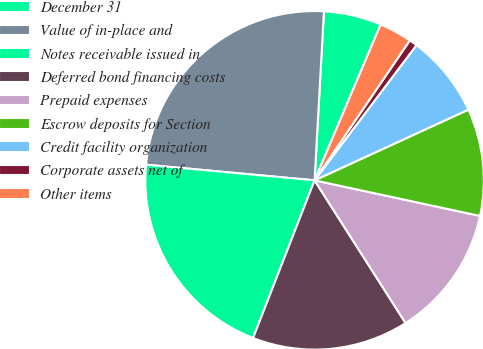<chart> <loc_0><loc_0><loc_500><loc_500><pie_chart><fcel>December 31<fcel>Value of in-place and<fcel>Notes receivable issued in<fcel>Deferred bond financing costs<fcel>Prepaid expenses<fcel>Escrow deposits for Section<fcel>Credit facility organization<fcel>Corporate assets net of<fcel>Other items<nl><fcel>5.5%<fcel>24.41%<fcel>20.55%<fcel>14.95%<fcel>12.59%<fcel>10.23%<fcel>7.86%<fcel>0.77%<fcel>3.13%<nl></chart> 